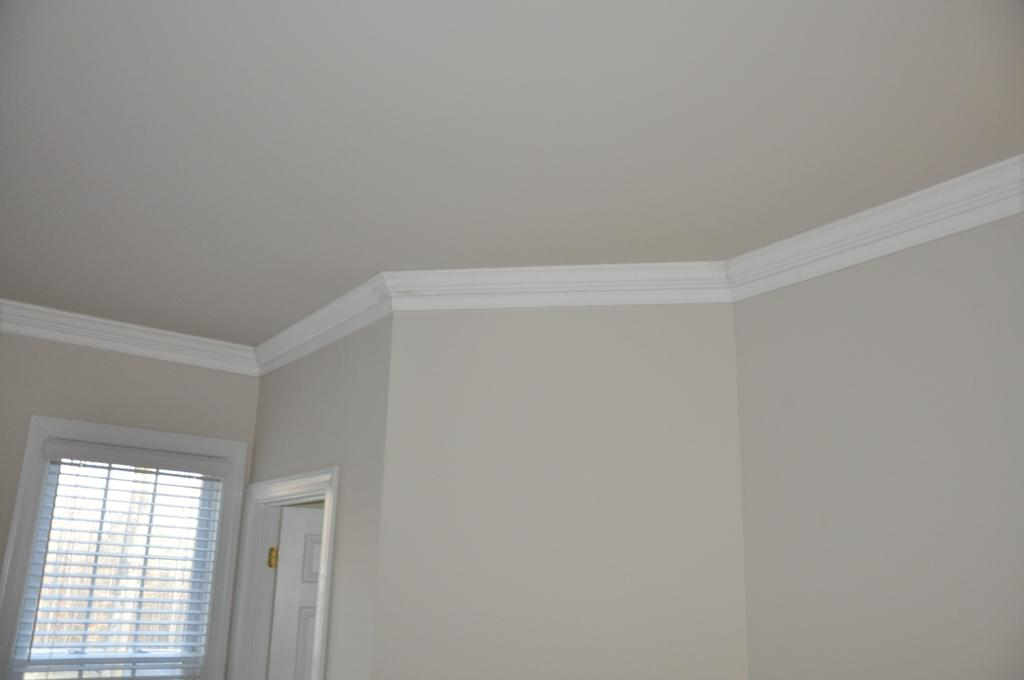What type of space is depicted in the image? The image is of a room. What feature allows natural light to enter the room? There is a window in the room. What color is the window in the image? The window is white. How can someone enter or exit the room? There is a door in the room. What color is the door in the image? The door is white. What type of animal is wearing a stocking in the image? There is no animal or stocking present in the image. 